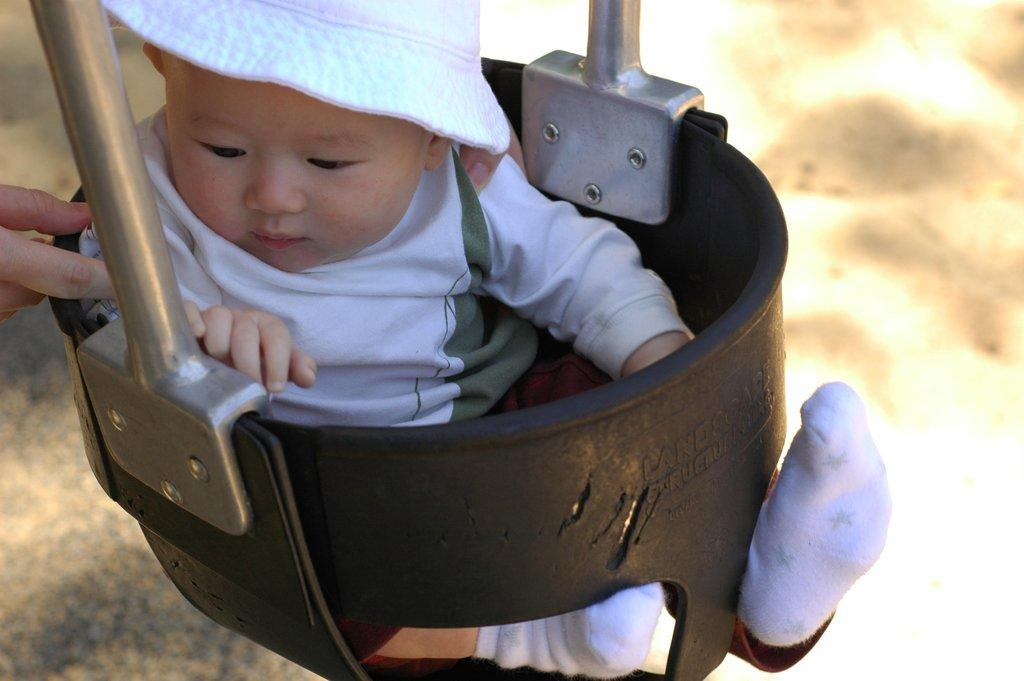Who is the main subject in the picture? There is a boy in the picture. What is the boy wearing on his head? The boy is wearing a hat. What type of clothing is the boy wearing on his upper body? The boy is wearing a t-shirt. What type of clothing is the boy wearing on his lower body? The boy is wearing shorts. What type of footwear is the boy wearing? The boy is wearing socks. What is the boy sitting on in the picture? The boy is sitting on a basket. Can you describe the presence of another person in the image? There is a person's hand on the left side of the image. What type of lettuce is being used as a yoke for the oxen in the image? There is no lettuce or oxen present in the image; it features a boy sitting on a basket with a person's hand on the left side. 